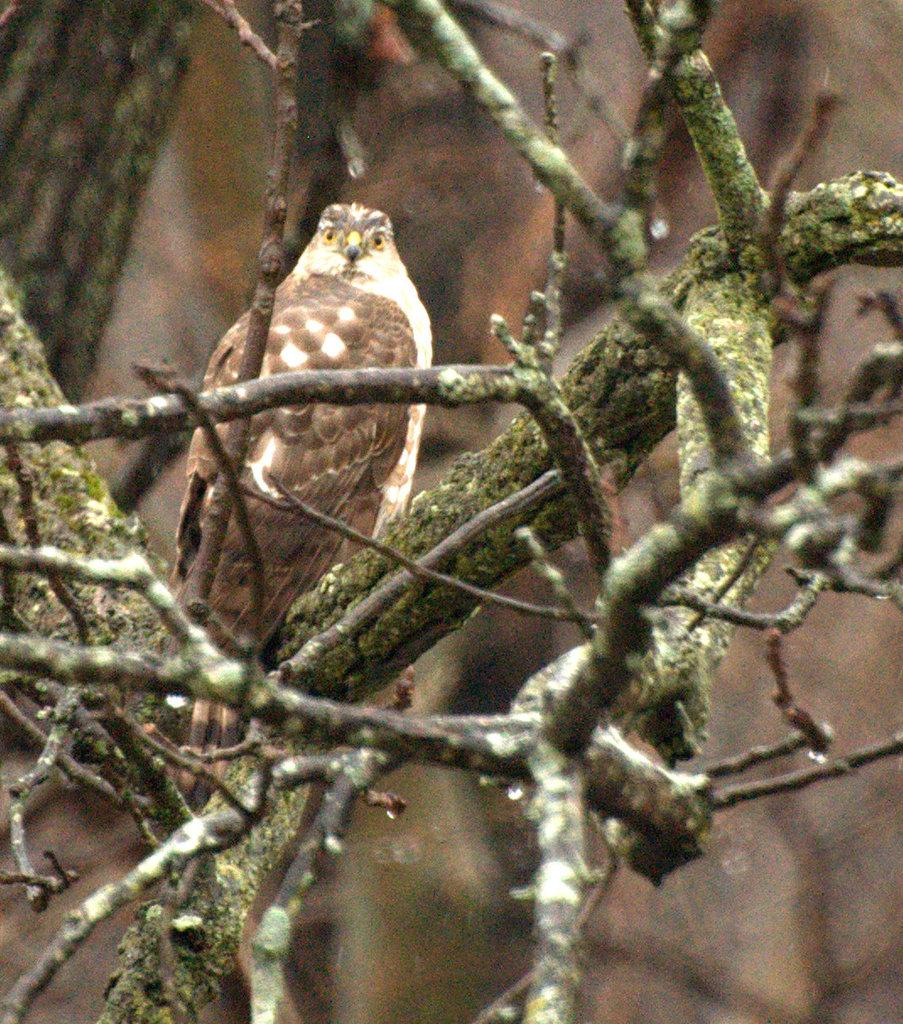What animal is present in the image? There is an owl in the image. Where is the owl located? The owl is sitting on a tree. What is the color of the owl? The owl is brown in color. What part of the tree can be seen in the image? The stems of the tree are visible in the image. How would you describe the background of the image? The background of the image is blurred. What type of parcel is being delivered by the owl in the image? There is no parcel present in the image, and the owl is not delivering anything. What effect does the owl have on the tree in the image? The owl is simply sitting on the tree, so it does not have any effect on the tree. 